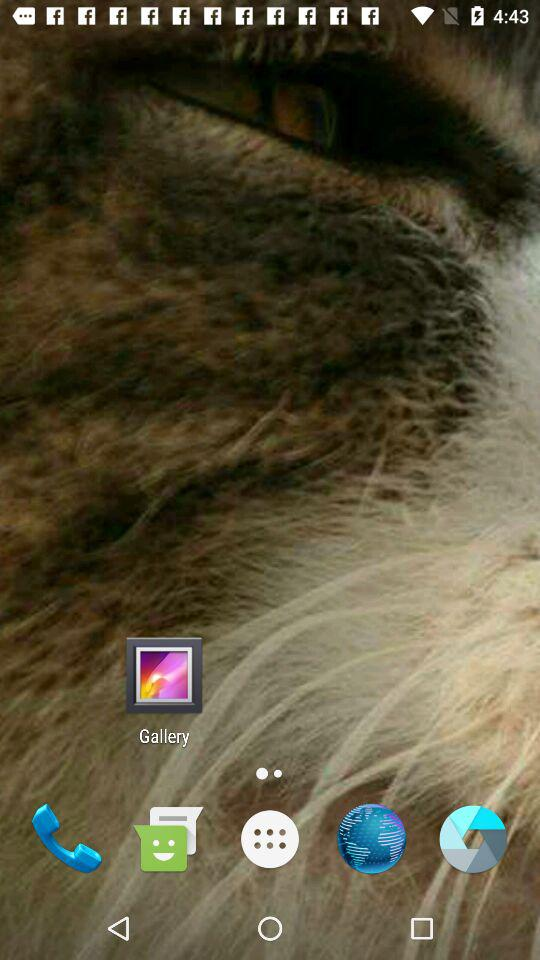What's the status of "Today's match"? The status of "Today's match" is "on". 